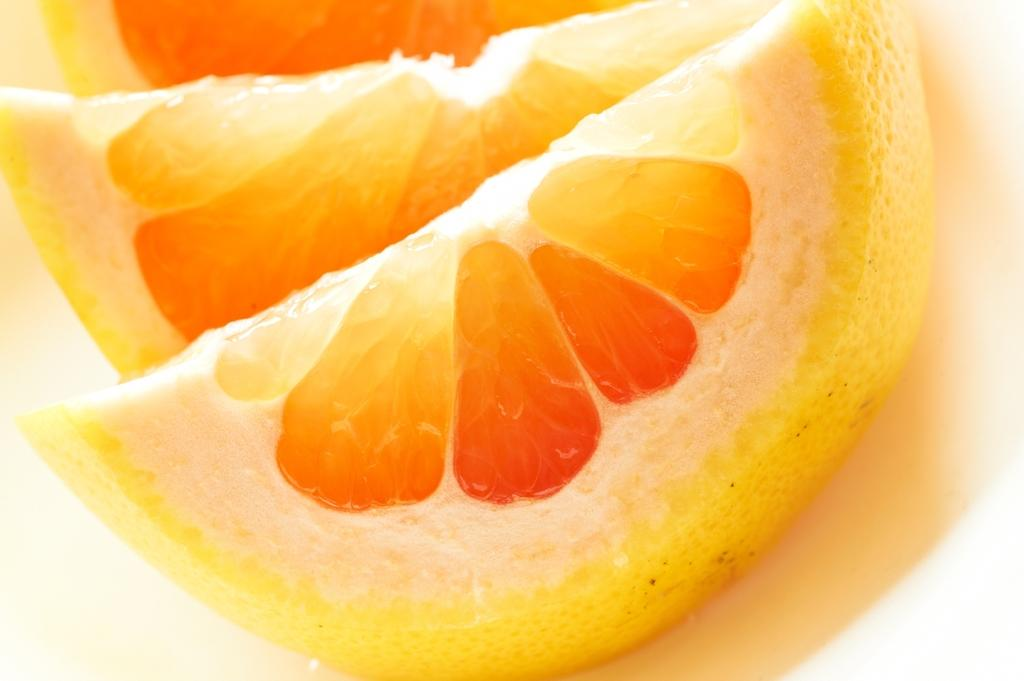What type of fruit is visible in the image? There are orange slices in the image. What is the lunchroom like in the image? There is no lunchroom present in the image; it only features orange slices. How does the stomach appear in the image? There is no stomach visible in the image; it only features orange slices. 